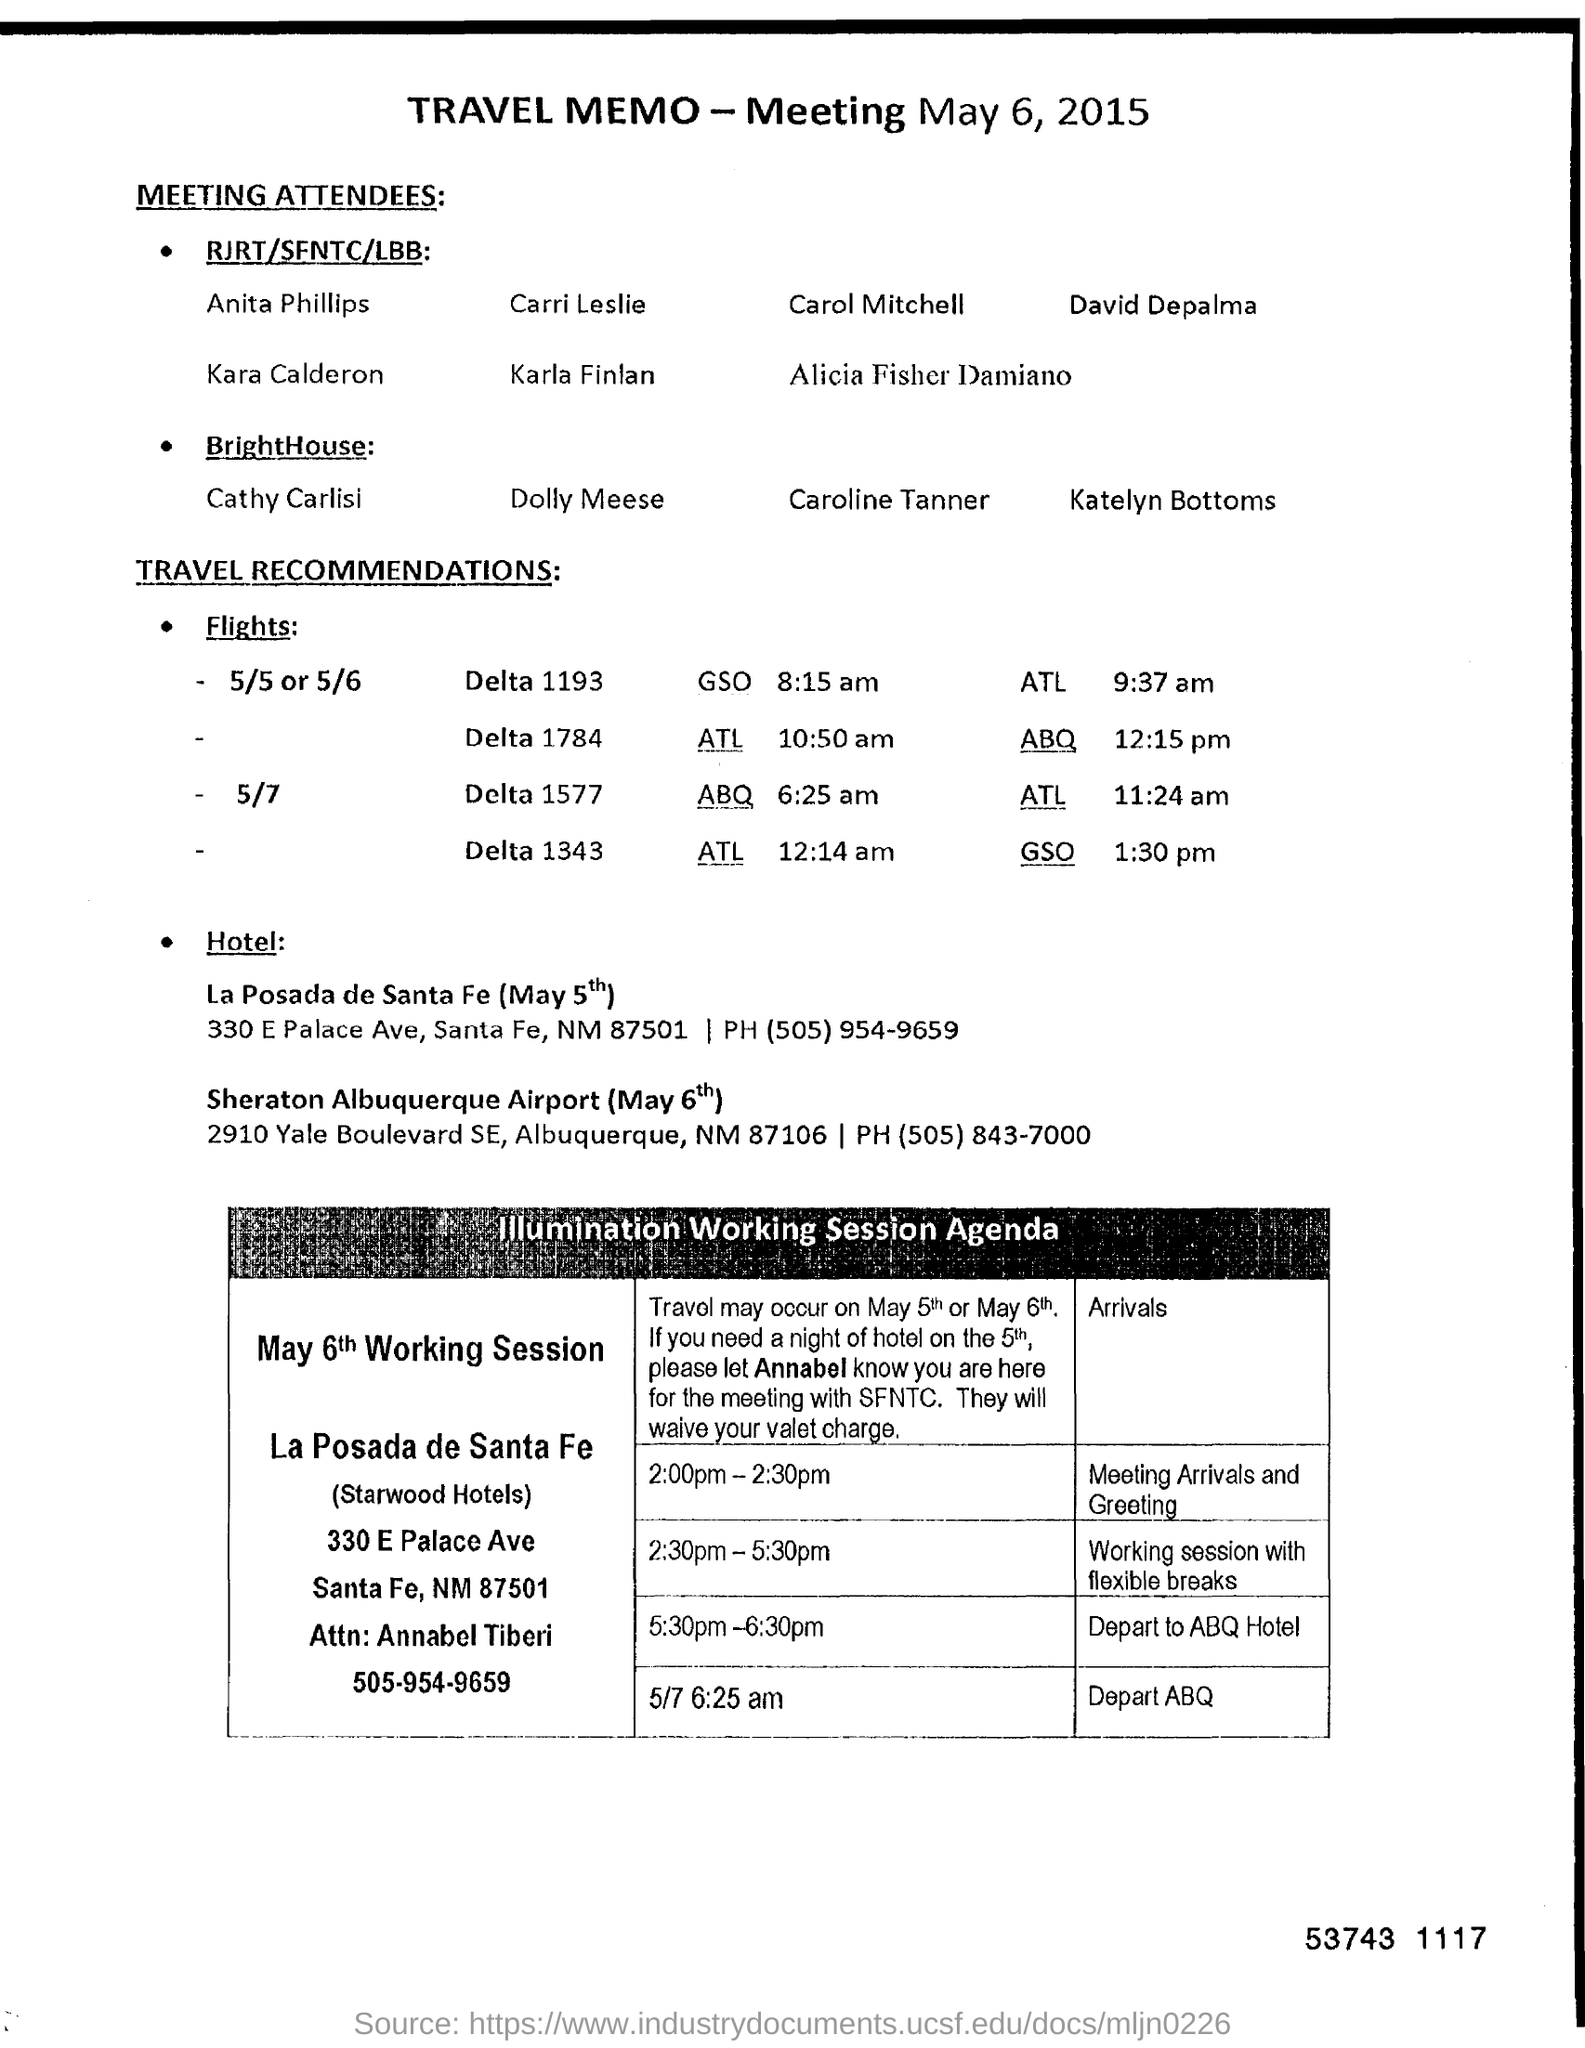What is the contact number of annabel tiberi ?
Provide a short and direct response. 505-954-9659. 